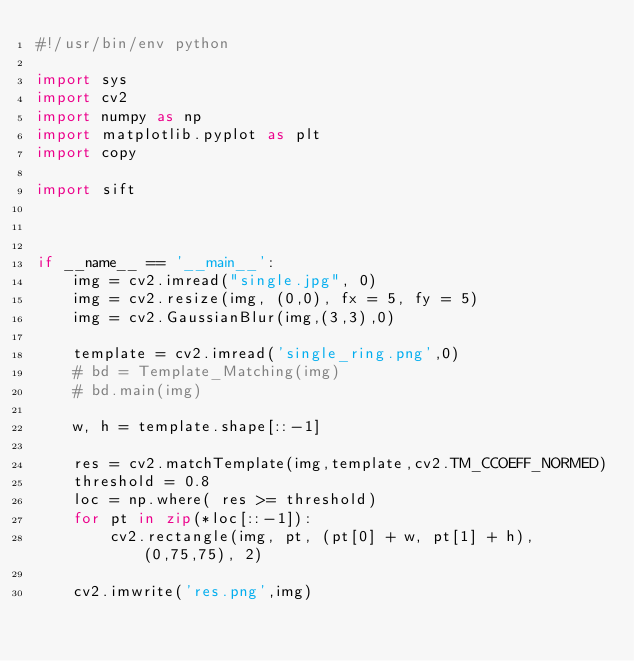Convert code to text. <code><loc_0><loc_0><loc_500><loc_500><_Python_>#!/usr/bin/env python 

import sys
import cv2
import numpy as np
import matplotlib.pyplot as plt
import copy

import sift



if __name__ == '__main__':
    img = cv2.imread("single.jpg", 0)
    img = cv2.resize(img, (0,0), fx = 5, fy = 5) 
    img = cv2.GaussianBlur(img,(3,3),0)

    template = cv2.imread('single_ring.png',0)
    # bd = Template_Matching(img)
    # bd.main(img)

    w, h = template.shape[::-1]

    res = cv2.matchTemplate(img,template,cv2.TM_CCOEFF_NORMED)
    threshold = 0.8
    loc = np.where( res >= threshold)
    for pt in zip(*loc[::-1]):
        cv2.rectangle(img, pt, (pt[0] + w, pt[1] + h), (0,75,75), 2)

    cv2.imwrite('res.png',img)</code> 